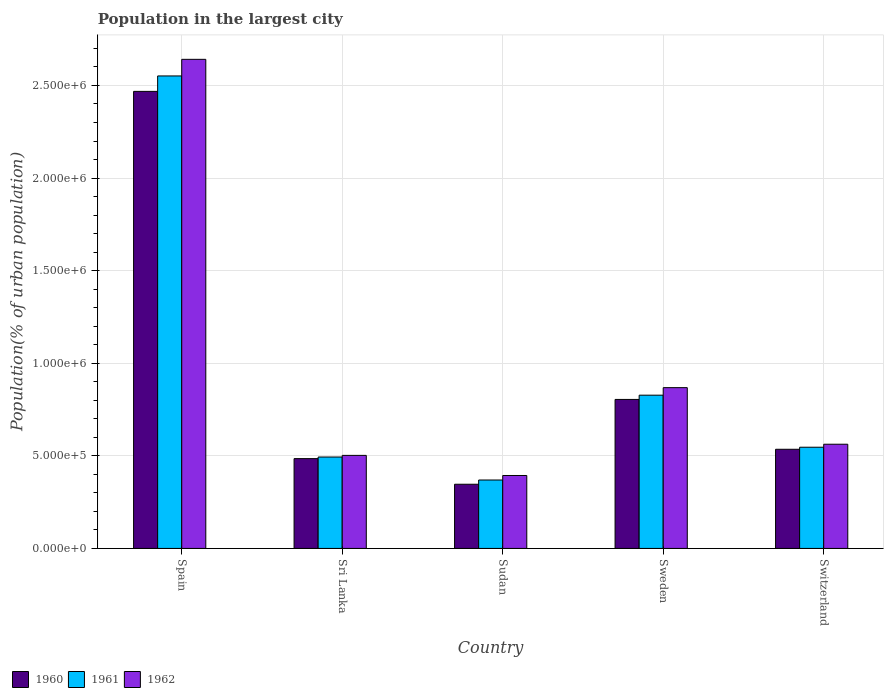Are the number of bars on each tick of the X-axis equal?
Ensure brevity in your answer.  Yes. How many bars are there on the 1st tick from the left?
Your answer should be compact. 3. How many bars are there on the 4th tick from the right?
Your answer should be compact. 3. In how many cases, is the number of bars for a given country not equal to the number of legend labels?
Provide a succinct answer. 0. What is the population in the largest city in 1962 in Sweden?
Ensure brevity in your answer.  8.68e+05. Across all countries, what is the maximum population in the largest city in 1962?
Provide a short and direct response. 2.64e+06. Across all countries, what is the minimum population in the largest city in 1962?
Your answer should be very brief. 3.94e+05. In which country was the population in the largest city in 1962 minimum?
Give a very brief answer. Sudan. What is the total population in the largest city in 1961 in the graph?
Your answer should be compact. 4.79e+06. What is the difference between the population in the largest city in 1961 in Spain and that in Sri Lanka?
Your answer should be compact. 2.06e+06. What is the difference between the population in the largest city in 1960 in Switzerland and the population in the largest city in 1962 in Sri Lanka?
Give a very brief answer. 3.30e+04. What is the average population in the largest city in 1960 per country?
Provide a succinct answer. 9.28e+05. What is the difference between the population in the largest city of/in 1960 and population in the largest city of/in 1962 in Sweden?
Provide a short and direct response. -6.36e+04. In how many countries, is the population in the largest city in 1961 greater than 100000 %?
Provide a short and direct response. 5. What is the ratio of the population in the largest city in 1962 in Sri Lanka to that in Switzerland?
Offer a very short reply. 0.89. What is the difference between the highest and the second highest population in the largest city in 1961?
Your response must be concise. -2.00e+06. What is the difference between the highest and the lowest population in the largest city in 1961?
Provide a short and direct response. 2.18e+06. In how many countries, is the population in the largest city in 1962 greater than the average population in the largest city in 1962 taken over all countries?
Your answer should be very brief. 1. What does the 2nd bar from the right in Sweden represents?
Offer a terse response. 1961. Is it the case that in every country, the sum of the population in the largest city in 1961 and population in the largest city in 1962 is greater than the population in the largest city in 1960?
Your answer should be compact. Yes. What is the difference between two consecutive major ticks on the Y-axis?
Make the answer very short. 5.00e+05. Does the graph contain grids?
Provide a short and direct response. Yes. Where does the legend appear in the graph?
Offer a very short reply. Bottom left. How many legend labels are there?
Your answer should be very brief. 3. What is the title of the graph?
Provide a succinct answer. Population in the largest city. Does "2011" appear as one of the legend labels in the graph?
Make the answer very short. No. What is the label or title of the X-axis?
Your answer should be compact. Country. What is the label or title of the Y-axis?
Your answer should be compact. Population(% of urban population). What is the Population(% of urban population) of 1960 in Spain?
Offer a very short reply. 2.47e+06. What is the Population(% of urban population) in 1961 in Spain?
Provide a short and direct response. 2.55e+06. What is the Population(% of urban population) in 1962 in Spain?
Your response must be concise. 2.64e+06. What is the Population(% of urban population) in 1960 in Sri Lanka?
Provide a succinct answer. 4.85e+05. What is the Population(% of urban population) of 1961 in Sri Lanka?
Offer a terse response. 4.94e+05. What is the Population(% of urban population) of 1962 in Sri Lanka?
Make the answer very short. 5.02e+05. What is the Population(% of urban population) of 1960 in Sudan?
Offer a very short reply. 3.47e+05. What is the Population(% of urban population) of 1961 in Sudan?
Provide a short and direct response. 3.69e+05. What is the Population(% of urban population) in 1962 in Sudan?
Provide a succinct answer. 3.94e+05. What is the Population(% of urban population) in 1960 in Sweden?
Provide a short and direct response. 8.05e+05. What is the Population(% of urban population) in 1961 in Sweden?
Offer a very short reply. 8.27e+05. What is the Population(% of urban population) in 1962 in Sweden?
Your response must be concise. 8.68e+05. What is the Population(% of urban population) of 1960 in Switzerland?
Provide a short and direct response. 5.35e+05. What is the Population(% of urban population) in 1961 in Switzerland?
Your response must be concise. 5.46e+05. What is the Population(% of urban population) of 1962 in Switzerland?
Offer a very short reply. 5.63e+05. Across all countries, what is the maximum Population(% of urban population) of 1960?
Your answer should be compact. 2.47e+06. Across all countries, what is the maximum Population(% of urban population) of 1961?
Your response must be concise. 2.55e+06. Across all countries, what is the maximum Population(% of urban population) in 1962?
Your answer should be very brief. 2.64e+06. Across all countries, what is the minimum Population(% of urban population) in 1960?
Offer a terse response. 3.47e+05. Across all countries, what is the minimum Population(% of urban population) in 1961?
Provide a short and direct response. 3.69e+05. Across all countries, what is the minimum Population(% of urban population) in 1962?
Keep it short and to the point. 3.94e+05. What is the total Population(% of urban population) in 1960 in the graph?
Your answer should be compact. 4.64e+06. What is the total Population(% of urban population) in 1961 in the graph?
Make the answer very short. 4.79e+06. What is the total Population(% of urban population) of 1962 in the graph?
Make the answer very short. 4.97e+06. What is the difference between the Population(% of urban population) of 1960 in Spain and that in Sri Lanka?
Your answer should be compact. 1.98e+06. What is the difference between the Population(% of urban population) of 1961 in Spain and that in Sri Lanka?
Offer a very short reply. 2.06e+06. What is the difference between the Population(% of urban population) of 1962 in Spain and that in Sri Lanka?
Offer a terse response. 2.14e+06. What is the difference between the Population(% of urban population) of 1960 in Spain and that in Sudan?
Your answer should be very brief. 2.12e+06. What is the difference between the Population(% of urban population) in 1961 in Spain and that in Sudan?
Make the answer very short. 2.18e+06. What is the difference between the Population(% of urban population) of 1962 in Spain and that in Sudan?
Provide a succinct answer. 2.25e+06. What is the difference between the Population(% of urban population) of 1960 in Spain and that in Sweden?
Keep it short and to the point. 1.66e+06. What is the difference between the Population(% of urban population) in 1961 in Spain and that in Sweden?
Your answer should be very brief. 1.72e+06. What is the difference between the Population(% of urban population) in 1962 in Spain and that in Sweden?
Offer a very short reply. 1.77e+06. What is the difference between the Population(% of urban population) of 1960 in Spain and that in Switzerland?
Offer a terse response. 1.93e+06. What is the difference between the Population(% of urban population) of 1961 in Spain and that in Switzerland?
Provide a succinct answer. 2.00e+06. What is the difference between the Population(% of urban population) in 1962 in Spain and that in Switzerland?
Your answer should be very brief. 2.08e+06. What is the difference between the Population(% of urban population) in 1960 in Sri Lanka and that in Sudan?
Make the answer very short. 1.38e+05. What is the difference between the Population(% of urban population) in 1961 in Sri Lanka and that in Sudan?
Your response must be concise. 1.24e+05. What is the difference between the Population(% of urban population) in 1962 in Sri Lanka and that in Sudan?
Provide a short and direct response. 1.09e+05. What is the difference between the Population(% of urban population) of 1960 in Sri Lanka and that in Sweden?
Your response must be concise. -3.20e+05. What is the difference between the Population(% of urban population) of 1961 in Sri Lanka and that in Sweden?
Provide a succinct answer. -3.34e+05. What is the difference between the Population(% of urban population) of 1962 in Sri Lanka and that in Sweden?
Keep it short and to the point. -3.66e+05. What is the difference between the Population(% of urban population) of 1960 in Sri Lanka and that in Switzerland?
Your answer should be compact. -5.05e+04. What is the difference between the Population(% of urban population) in 1961 in Sri Lanka and that in Switzerland?
Keep it short and to the point. -5.28e+04. What is the difference between the Population(% of urban population) in 1962 in Sri Lanka and that in Switzerland?
Offer a very short reply. -6.02e+04. What is the difference between the Population(% of urban population) in 1960 in Sudan and that in Sweden?
Provide a short and direct response. -4.58e+05. What is the difference between the Population(% of urban population) of 1961 in Sudan and that in Sweden?
Your answer should be compact. -4.58e+05. What is the difference between the Population(% of urban population) of 1962 in Sudan and that in Sweden?
Your answer should be compact. -4.74e+05. What is the difference between the Population(% of urban population) in 1960 in Sudan and that in Switzerland?
Offer a very short reply. -1.89e+05. What is the difference between the Population(% of urban population) of 1961 in Sudan and that in Switzerland?
Ensure brevity in your answer.  -1.77e+05. What is the difference between the Population(% of urban population) in 1962 in Sudan and that in Switzerland?
Provide a short and direct response. -1.69e+05. What is the difference between the Population(% of urban population) of 1960 in Sweden and that in Switzerland?
Keep it short and to the point. 2.69e+05. What is the difference between the Population(% of urban population) in 1961 in Sweden and that in Switzerland?
Provide a succinct answer. 2.81e+05. What is the difference between the Population(% of urban population) of 1962 in Sweden and that in Switzerland?
Provide a short and direct response. 3.06e+05. What is the difference between the Population(% of urban population) in 1960 in Spain and the Population(% of urban population) in 1961 in Sri Lanka?
Your answer should be compact. 1.97e+06. What is the difference between the Population(% of urban population) of 1960 in Spain and the Population(% of urban population) of 1962 in Sri Lanka?
Provide a succinct answer. 1.97e+06. What is the difference between the Population(% of urban population) in 1961 in Spain and the Population(% of urban population) in 1962 in Sri Lanka?
Offer a very short reply. 2.05e+06. What is the difference between the Population(% of urban population) of 1960 in Spain and the Population(% of urban population) of 1961 in Sudan?
Offer a very short reply. 2.10e+06. What is the difference between the Population(% of urban population) in 1960 in Spain and the Population(% of urban population) in 1962 in Sudan?
Give a very brief answer. 2.07e+06. What is the difference between the Population(% of urban population) in 1961 in Spain and the Population(% of urban population) in 1962 in Sudan?
Provide a short and direct response. 2.16e+06. What is the difference between the Population(% of urban population) in 1960 in Spain and the Population(% of urban population) in 1961 in Sweden?
Your response must be concise. 1.64e+06. What is the difference between the Population(% of urban population) in 1960 in Spain and the Population(% of urban population) in 1962 in Sweden?
Keep it short and to the point. 1.60e+06. What is the difference between the Population(% of urban population) in 1961 in Spain and the Population(% of urban population) in 1962 in Sweden?
Provide a succinct answer. 1.68e+06. What is the difference between the Population(% of urban population) of 1960 in Spain and the Population(% of urban population) of 1961 in Switzerland?
Ensure brevity in your answer.  1.92e+06. What is the difference between the Population(% of urban population) in 1960 in Spain and the Population(% of urban population) in 1962 in Switzerland?
Provide a succinct answer. 1.91e+06. What is the difference between the Population(% of urban population) of 1961 in Spain and the Population(% of urban population) of 1962 in Switzerland?
Offer a terse response. 1.99e+06. What is the difference between the Population(% of urban population) of 1960 in Sri Lanka and the Population(% of urban population) of 1961 in Sudan?
Make the answer very short. 1.15e+05. What is the difference between the Population(% of urban population) of 1960 in Sri Lanka and the Population(% of urban population) of 1962 in Sudan?
Offer a terse response. 9.11e+04. What is the difference between the Population(% of urban population) of 1961 in Sri Lanka and the Population(% of urban population) of 1962 in Sudan?
Offer a very short reply. 9.97e+04. What is the difference between the Population(% of urban population) in 1960 in Sri Lanka and the Population(% of urban population) in 1961 in Sweden?
Your answer should be compact. -3.43e+05. What is the difference between the Population(% of urban population) in 1960 in Sri Lanka and the Population(% of urban population) in 1962 in Sweden?
Provide a short and direct response. -3.83e+05. What is the difference between the Population(% of urban population) of 1961 in Sri Lanka and the Population(% of urban population) of 1962 in Sweden?
Your response must be concise. -3.75e+05. What is the difference between the Population(% of urban population) in 1960 in Sri Lanka and the Population(% of urban population) in 1961 in Switzerland?
Offer a very short reply. -6.15e+04. What is the difference between the Population(% of urban population) in 1960 in Sri Lanka and the Population(% of urban population) in 1962 in Switzerland?
Provide a short and direct response. -7.77e+04. What is the difference between the Population(% of urban population) in 1961 in Sri Lanka and the Population(% of urban population) in 1962 in Switzerland?
Your answer should be very brief. -6.90e+04. What is the difference between the Population(% of urban population) of 1960 in Sudan and the Population(% of urban population) of 1961 in Sweden?
Your response must be concise. -4.81e+05. What is the difference between the Population(% of urban population) in 1960 in Sudan and the Population(% of urban population) in 1962 in Sweden?
Make the answer very short. -5.22e+05. What is the difference between the Population(% of urban population) in 1961 in Sudan and the Population(% of urban population) in 1962 in Sweden?
Ensure brevity in your answer.  -4.99e+05. What is the difference between the Population(% of urban population) of 1960 in Sudan and the Population(% of urban population) of 1961 in Switzerland?
Your answer should be very brief. -2.00e+05. What is the difference between the Population(% of urban population) in 1960 in Sudan and the Population(% of urban population) in 1962 in Switzerland?
Offer a very short reply. -2.16e+05. What is the difference between the Population(% of urban population) in 1961 in Sudan and the Population(% of urban population) in 1962 in Switzerland?
Your response must be concise. -1.93e+05. What is the difference between the Population(% of urban population) of 1960 in Sweden and the Population(% of urban population) of 1961 in Switzerland?
Make the answer very short. 2.58e+05. What is the difference between the Population(% of urban population) of 1960 in Sweden and the Population(% of urban population) of 1962 in Switzerland?
Your response must be concise. 2.42e+05. What is the difference between the Population(% of urban population) in 1961 in Sweden and the Population(% of urban population) in 1962 in Switzerland?
Provide a short and direct response. 2.65e+05. What is the average Population(% of urban population) in 1960 per country?
Give a very brief answer. 9.28e+05. What is the average Population(% of urban population) of 1961 per country?
Ensure brevity in your answer.  9.58e+05. What is the average Population(% of urban population) of 1962 per country?
Provide a succinct answer. 9.94e+05. What is the difference between the Population(% of urban population) in 1960 and Population(% of urban population) in 1961 in Spain?
Give a very brief answer. -8.34e+04. What is the difference between the Population(% of urban population) in 1960 and Population(% of urban population) in 1962 in Spain?
Ensure brevity in your answer.  -1.73e+05. What is the difference between the Population(% of urban population) of 1961 and Population(% of urban population) of 1962 in Spain?
Your answer should be compact. -8.97e+04. What is the difference between the Population(% of urban population) of 1960 and Population(% of urban population) of 1961 in Sri Lanka?
Provide a short and direct response. -8675. What is the difference between the Population(% of urban population) in 1960 and Population(% of urban population) in 1962 in Sri Lanka?
Offer a terse response. -1.75e+04. What is the difference between the Population(% of urban population) of 1961 and Population(% of urban population) of 1962 in Sri Lanka?
Your answer should be very brief. -8842. What is the difference between the Population(% of urban population) of 1960 and Population(% of urban population) of 1961 in Sudan?
Provide a short and direct response. -2.29e+04. What is the difference between the Population(% of urban population) in 1960 and Population(% of urban population) in 1962 in Sudan?
Provide a short and direct response. -4.73e+04. What is the difference between the Population(% of urban population) in 1961 and Population(% of urban population) in 1962 in Sudan?
Your answer should be compact. -2.44e+04. What is the difference between the Population(% of urban population) of 1960 and Population(% of urban population) of 1961 in Sweden?
Offer a terse response. -2.29e+04. What is the difference between the Population(% of urban population) of 1960 and Population(% of urban population) of 1962 in Sweden?
Provide a succinct answer. -6.36e+04. What is the difference between the Population(% of urban population) of 1961 and Population(% of urban population) of 1962 in Sweden?
Keep it short and to the point. -4.07e+04. What is the difference between the Population(% of urban population) of 1960 and Population(% of urban population) of 1961 in Switzerland?
Provide a short and direct response. -1.10e+04. What is the difference between the Population(% of urban population) of 1960 and Population(% of urban population) of 1962 in Switzerland?
Your response must be concise. -2.72e+04. What is the difference between the Population(% of urban population) in 1961 and Population(% of urban population) in 1962 in Switzerland?
Ensure brevity in your answer.  -1.62e+04. What is the ratio of the Population(% of urban population) in 1960 in Spain to that in Sri Lanka?
Your answer should be very brief. 5.09. What is the ratio of the Population(% of urban population) of 1961 in Spain to that in Sri Lanka?
Give a very brief answer. 5.17. What is the ratio of the Population(% of urban population) in 1962 in Spain to that in Sri Lanka?
Make the answer very short. 5.26. What is the ratio of the Population(% of urban population) in 1960 in Spain to that in Sudan?
Give a very brief answer. 7.12. What is the ratio of the Population(% of urban population) in 1961 in Spain to that in Sudan?
Keep it short and to the point. 6.91. What is the ratio of the Population(% of urban population) of 1962 in Spain to that in Sudan?
Provide a succinct answer. 6.7. What is the ratio of the Population(% of urban population) in 1960 in Spain to that in Sweden?
Offer a terse response. 3.07. What is the ratio of the Population(% of urban population) of 1961 in Spain to that in Sweden?
Offer a terse response. 3.08. What is the ratio of the Population(% of urban population) of 1962 in Spain to that in Sweden?
Offer a terse response. 3.04. What is the ratio of the Population(% of urban population) in 1960 in Spain to that in Switzerland?
Keep it short and to the point. 4.61. What is the ratio of the Population(% of urban population) in 1961 in Spain to that in Switzerland?
Your answer should be compact. 4.67. What is the ratio of the Population(% of urban population) in 1962 in Spain to that in Switzerland?
Make the answer very short. 4.69. What is the ratio of the Population(% of urban population) in 1960 in Sri Lanka to that in Sudan?
Provide a succinct answer. 1.4. What is the ratio of the Population(% of urban population) of 1961 in Sri Lanka to that in Sudan?
Your answer should be very brief. 1.34. What is the ratio of the Population(% of urban population) in 1962 in Sri Lanka to that in Sudan?
Make the answer very short. 1.28. What is the ratio of the Population(% of urban population) in 1960 in Sri Lanka to that in Sweden?
Offer a very short reply. 0.6. What is the ratio of the Population(% of urban population) of 1961 in Sri Lanka to that in Sweden?
Your answer should be compact. 0.6. What is the ratio of the Population(% of urban population) of 1962 in Sri Lanka to that in Sweden?
Offer a very short reply. 0.58. What is the ratio of the Population(% of urban population) of 1960 in Sri Lanka to that in Switzerland?
Ensure brevity in your answer.  0.91. What is the ratio of the Population(% of urban population) of 1961 in Sri Lanka to that in Switzerland?
Provide a short and direct response. 0.9. What is the ratio of the Population(% of urban population) of 1962 in Sri Lanka to that in Switzerland?
Your answer should be very brief. 0.89. What is the ratio of the Population(% of urban population) of 1960 in Sudan to that in Sweden?
Keep it short and to the point. 0.43. What is the ratio of the Population(% of urban population) of 1961 in Sudan to that in Sweden?
Your answer should be very brief. 0.45. What is the ratio of the Population(% of urban population) in 1962 in Sudan to that in Sweden?
Your answer should be very brief. 0.45. What is the ratio of the Population(% of urban population) of 1960 in Sudan to that in Switzerland?
Your response must be concise. 0.65. What is the ratio of the Population(% of urban population) in 1961 in Sudan to that in Switzerland?
Your response must be concise. 0.68. What is the ratio of the Population(% of urban population) in 1962 in Sudan to that in Switzerland?
Your answer should be compact. 0.7. What is the ratio of the Population(% of urban population) of 1960 in Sweden to that in Switzerland?
Keep it short and to the point. 1.5. What is the ratio of the Population(% of urban population) in 1961 in Sweden to that in Switzerland?
Keep it short and to the point. 1.51. What is the ratio of the Population(% of urban population) in 1962 in Sweden to that in Switzerland?
Your response must be concise. 1.54. What is the difference between the highest and the second highest Population(% of urban population) in 1960?
Provide a succinct answer. 1.66e+06. What is the difference between the highest and the second highest Population(% of urban population) of 1961?
Keep it short and to the point. 1.72e+06. What is the difference between the highest and the second highest Population(% of urban population) in 1962?
Ensure brevity in your answer.  1.77e+06. What is the difference between the highest and the lowest Population(% of urban population) in 1960?
Make the answer very short. 2.12e+06. What is the difference between the highest and the lowest Population(% of urban population) of 1961?
Your answer should be very brief. 2.18e+06. What is the difference between the highest and the lowest Population(% of urban population) in 1962?
Ensure brevity in your answer.  2.25e+06. 